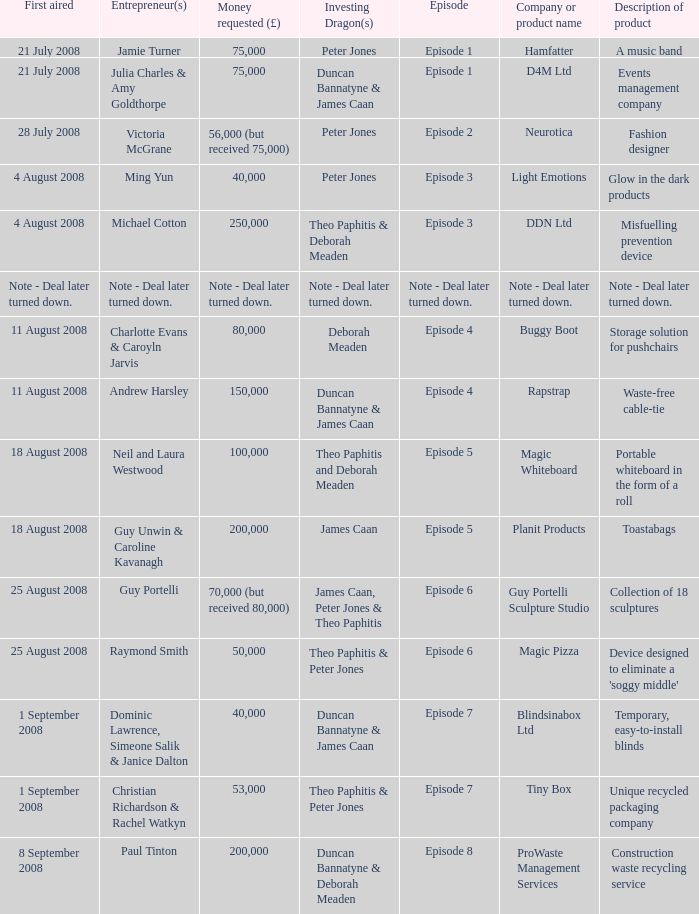When did episode 6 first air with entrepreneur Guy Portelli? 25 August 2008. 